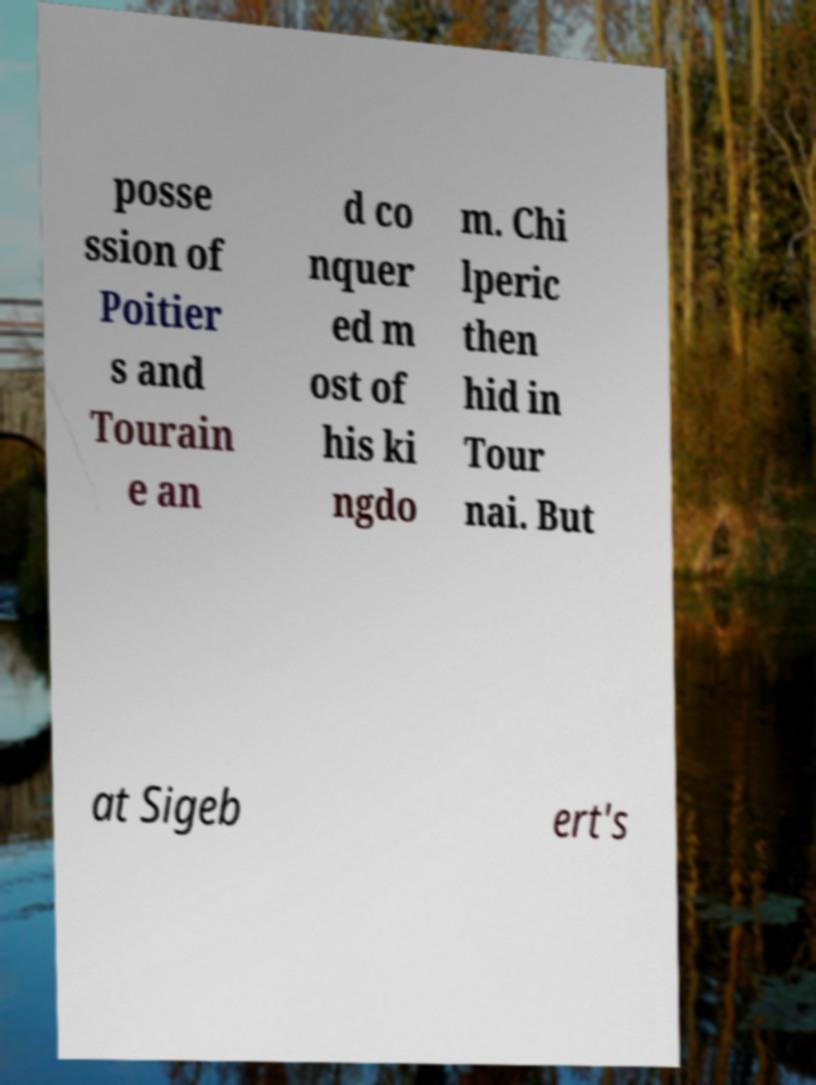Could you extract and type out the text from this image? posse ssion of Poitier s and Tourain e an d co nquer ed m ost of his ki ngdo m. Chi lperic then hid in Tour nai. But at Sigeb ert's 